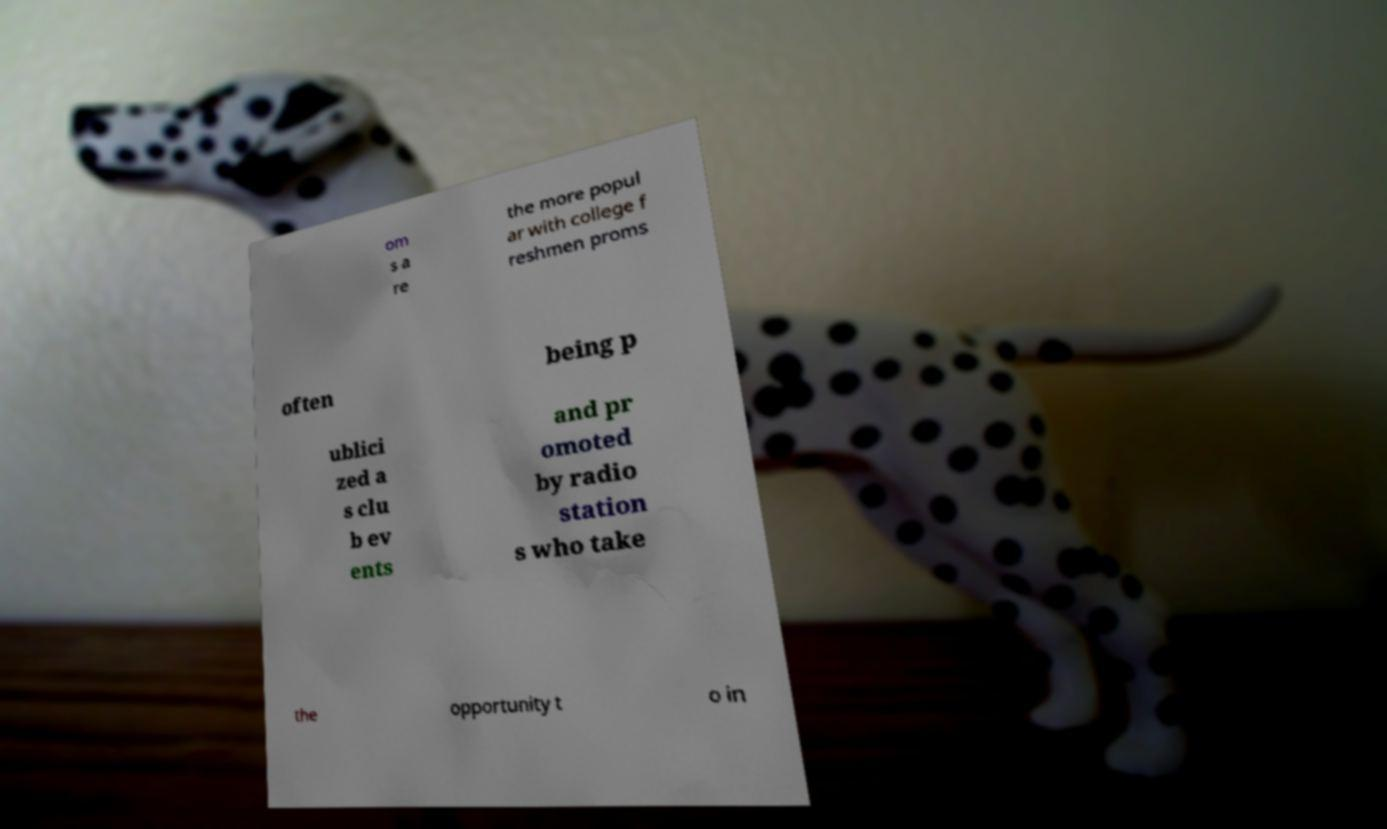Please read and relay the text visible in this image. What does it say? om s a re the more popul ar with college f reshmen proms often being p ublici zed a s clu b ev ents and pr omoted by radio station s who take the opportunity t o in 